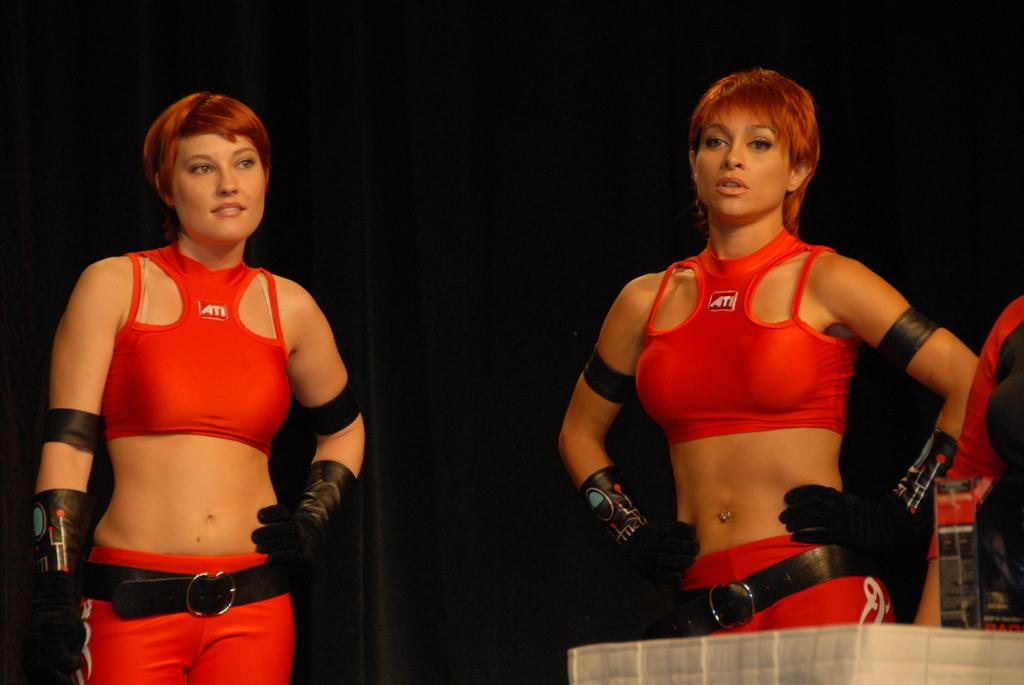<image>
Provide a brief description of the given image. The two ladies pictured are wearing tops by Ati. 